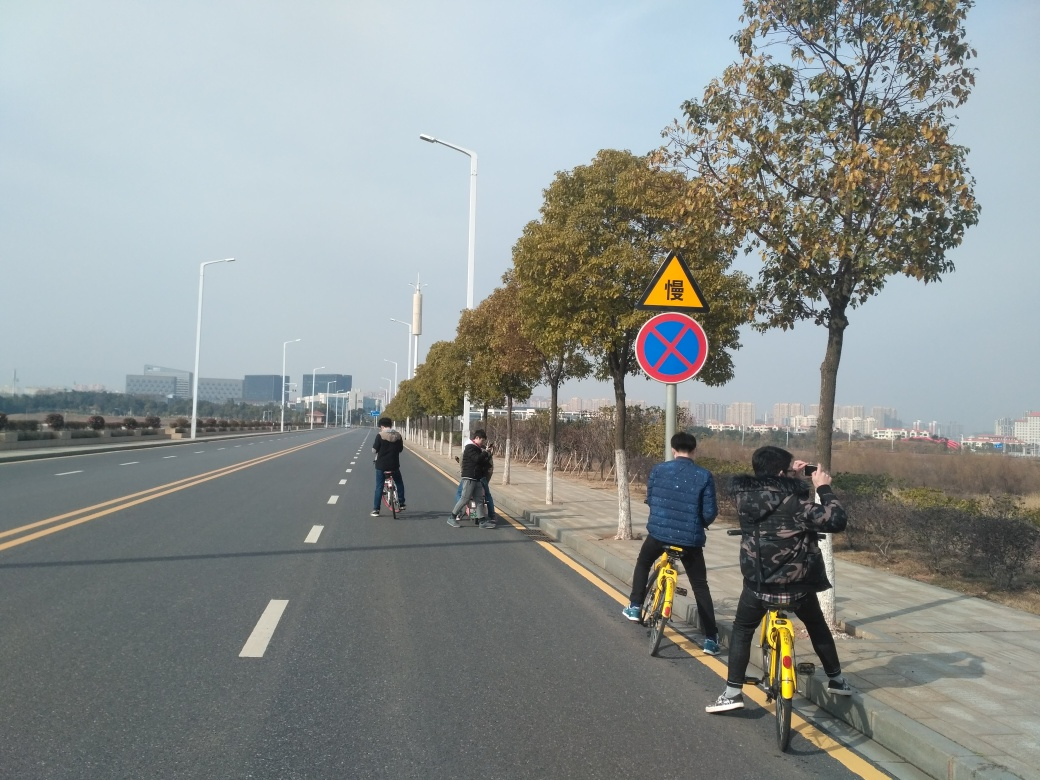What weather conditions are depicted in this image? The weather in the image appears to be clear and sunny. There are no visible clouds in the sky, suggesting a fair weather condition conducive for outdoor activities like cycling. 